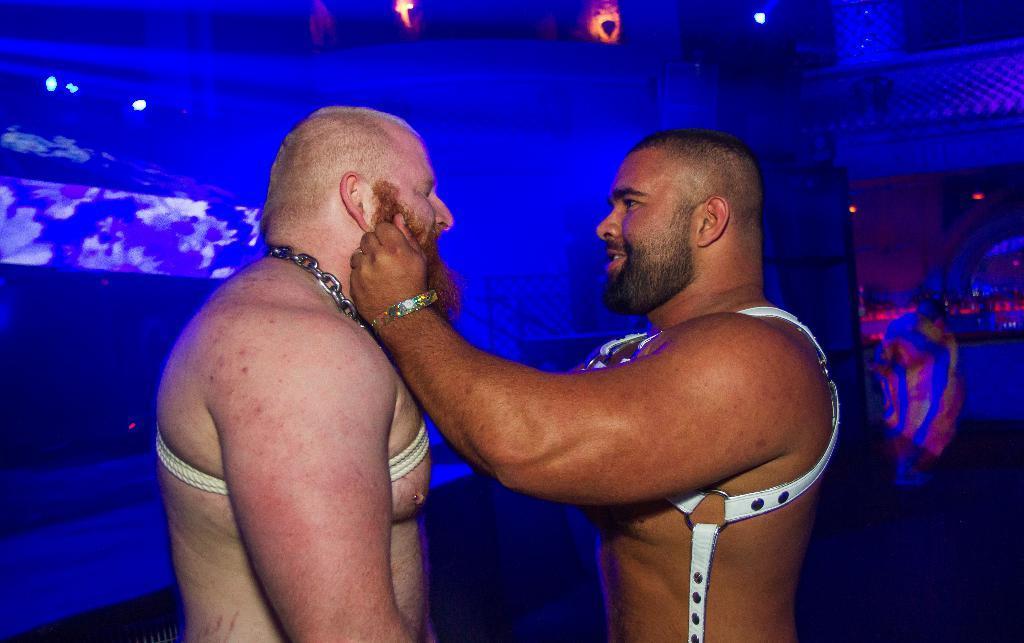Please provide a concise description of this image. The person in the right is standing and holding the beard of another person standing in front of him and the background is blue in color. 